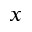Convert formula to latex. <formula><loc_0><loc_0><loc_500><loc_500>x</formula> 